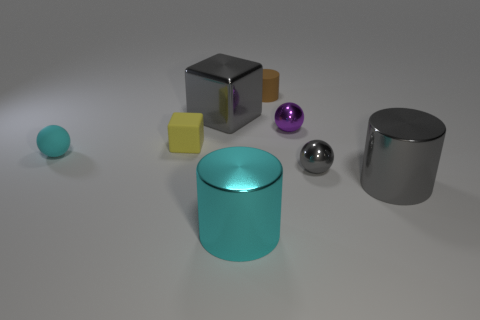How many small brown rubber cylinders are to the right of the large cube?
Provide a short and direct response. 1. Is the material of the big cylinder right of the tiny brown object the same as the cyan cylinder?
Keep it short and to the point. Yes. What color is the other tiny matte thing that is the same shape as the small gray object?
Your answer should be very brief. Cyan. The large cyan metal object has what shape?
Give a very brief answer. Cylinder. What number of objects are small red metal cylinders or tiny things?
Your answer should be very brief. 5. There is a small metallic object in front of the purple ball; is its color the same as the small matte object that is in front of the yellow matte block?
Your answer should be very brief. No. How many other things are there of the same shape as the small gray shiny thing?
Offer a very short reply. 2. Is there a large gray matte cylinder?
Offer a very short reply. No. What number of things are tiny red metallic blocks or big gray objects that are in front of the tiny cylinder?
Your answer should be very brief. 2. There is a ball that is on the left side of the brown thing; is its size the same as the rubber cylinder?
Your answer should be compact. Yes. 